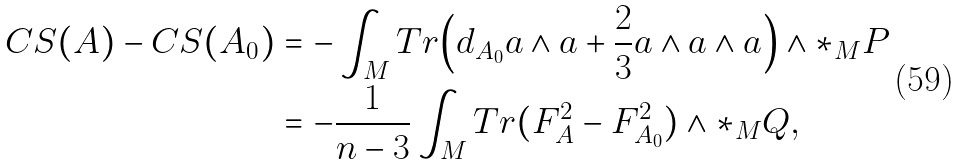Convert formula to latex. <formula><loc_0><loc_0><loc_500><loc_500>C S ( A ) - C S ( A _ { 0 } ) & = - \int _ { M } T r \Big { ( } d _ { A _ { 0 } } a \wedge { a } + \frac { 2 } { 3 } a \wedge a \wedge a \Big { ) } \wedge \ast _ { M } P \\ & = - \frac { 1 } { n - 3 } \int _ { M } T r ( F ^ { 2 } _ { A } - F ^ { 2 } _ { A _ { 0 } } ) \wedge \ast _ { M } Q , \\</formula> 